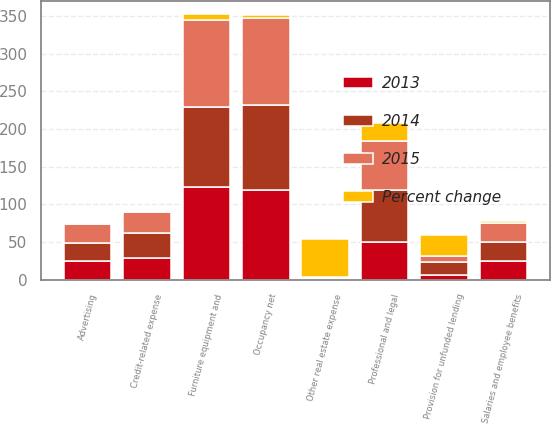Convert chart. <chart><loc_0><loc_0><loc_500><loc_500><stacked_bar_chart><ecel><fcel>Salaries and employee benefits<fcel>Occupancy net<fcel>Furniture equipment and<fcel>Other real estate expense<fcel>Credit-related expense<fcel>Provision for unfunded lending<fcel>Professional and legal<fcel>Advertising<nl><fcel>2013<fcel>25.3<fcel>119.5<fcel>123.2<fcel>0.6<fcel>28.5<fcel>6.2<fcel>50.4<fcel>25.3<nl><fcel>Percent change<fcel>1.7<fcel>3.3<fcel>6.9<fcel>50<fcel>1.4<fcel>27.9<fcel>23.6<fcel>0.8<nl><fcel>2015<fcel>25.3<fcel>115.7<fcel>115.3<fcel>1.2<fcel>28.1<fcel>8.6<fcel>66<fcel>25.1<nl><fcel>2014<fcel>25.3<fcel>112.3<fcel>106.6<fcel>1.7<fcel>33.8<fcel>17.1<fcel>68<fcel>23.4<nl></chart> 